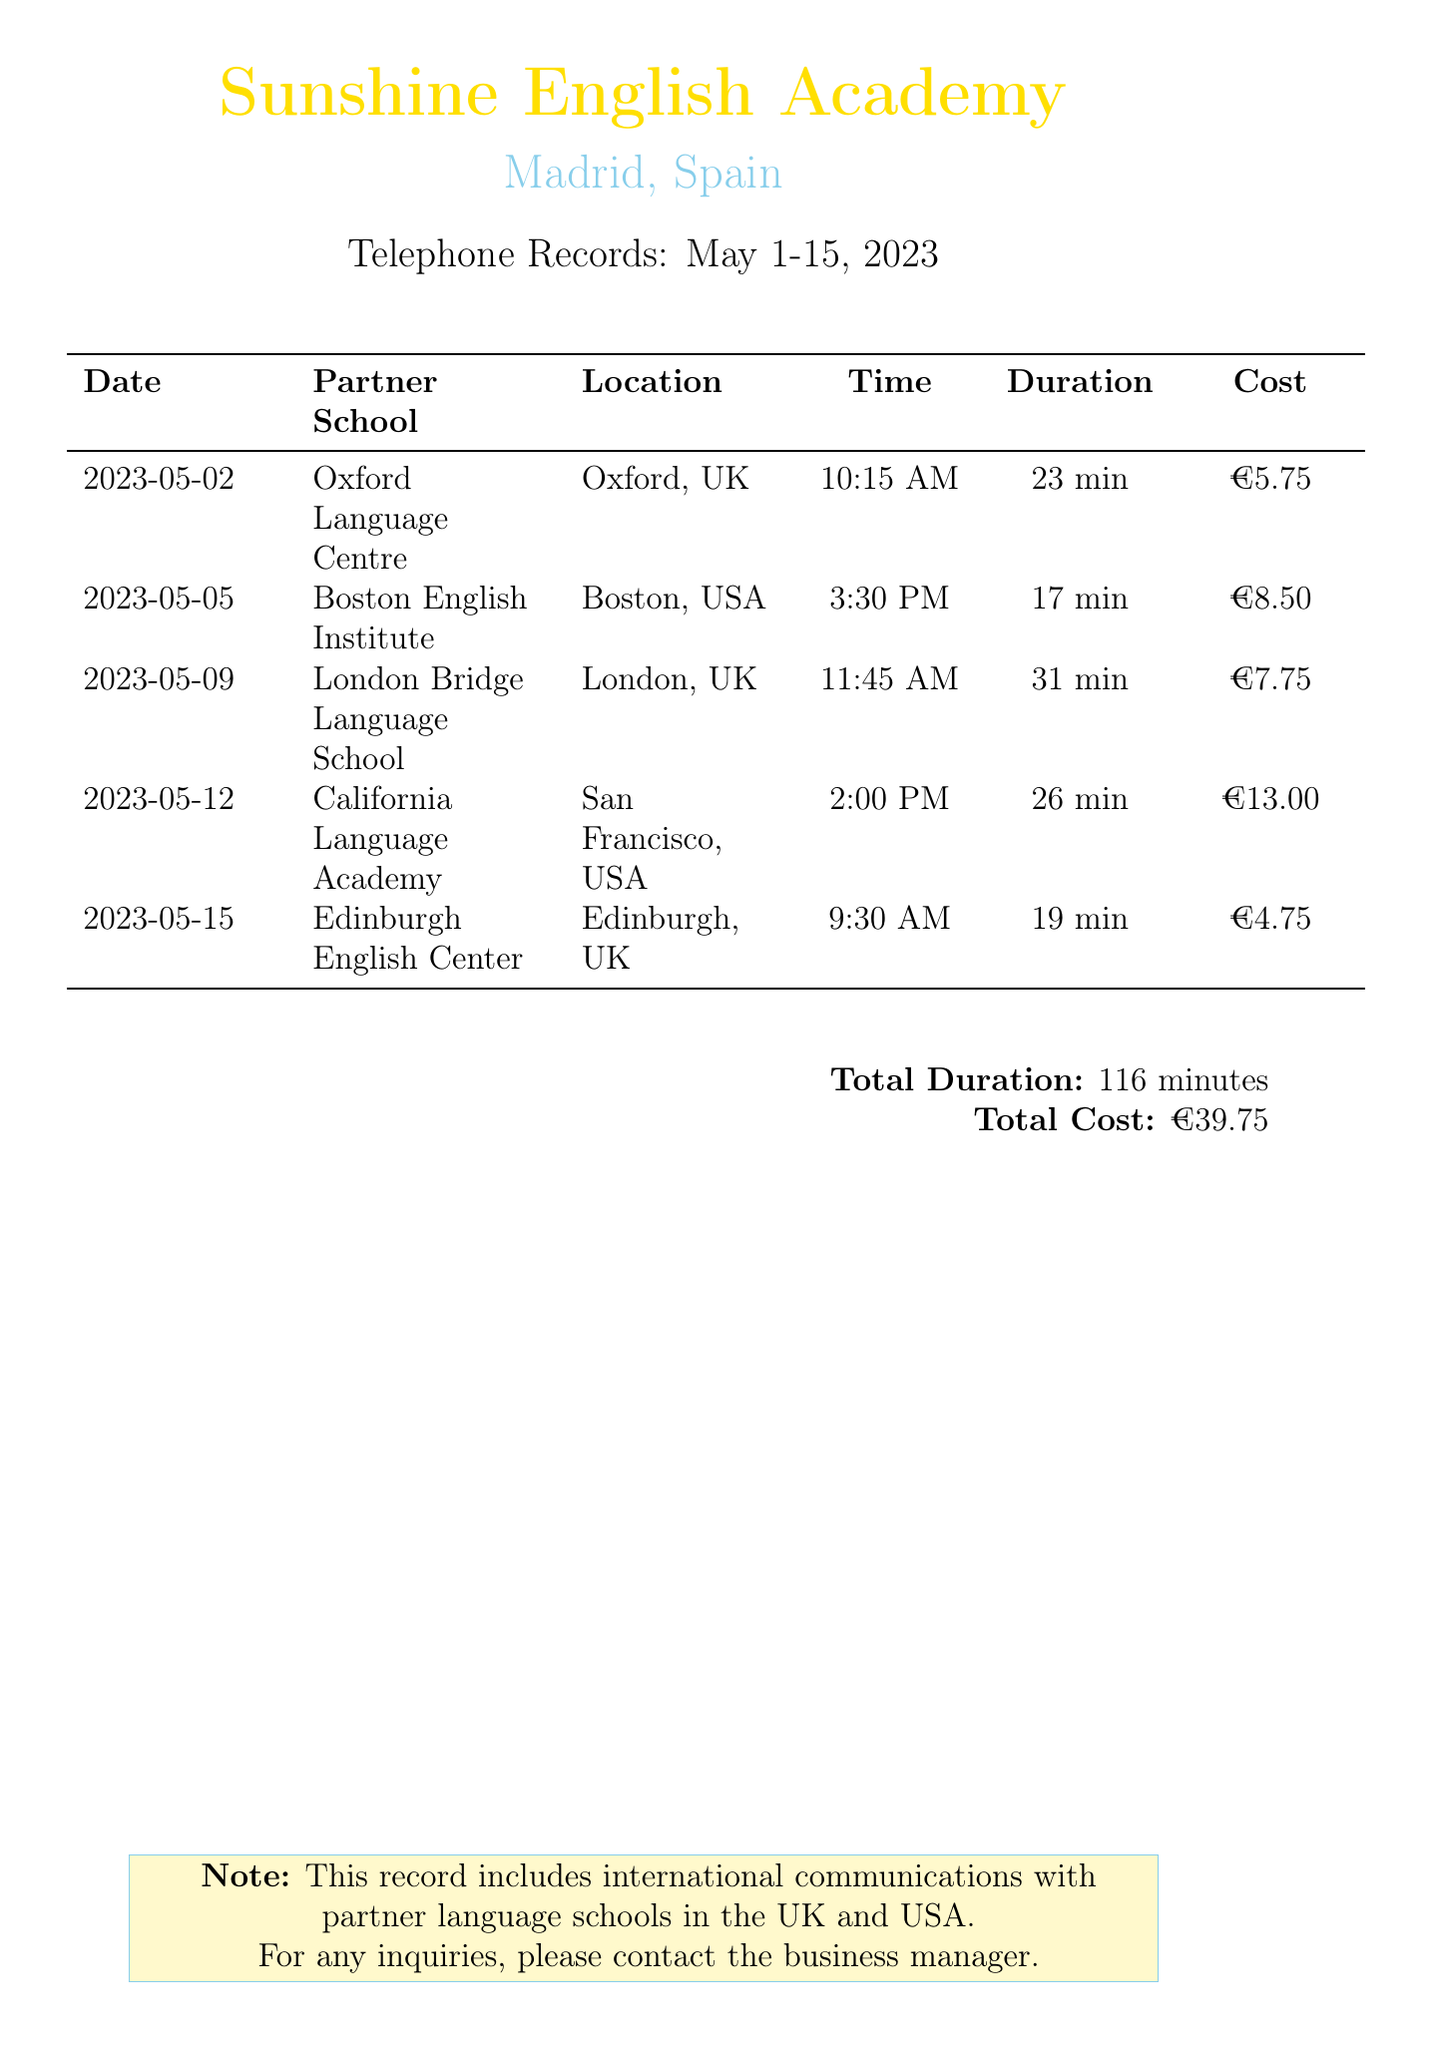What is the total duration of calls? The total duration is stated at the bottom of the document, which adds the duration of all calls made during the specified period.
Answer: 116 minutes What is the cost of the call with California Language Academy? This cost is directly listed in the call log for that particular call.
Answer: €13.00 How long was the call with the Oxford Language Centre? The duration for this call is provided in the detailed table of calls.
Answer: 23 min On what date was the call to Boston English Institute made? The date is clearly indicated in the corresponding row of the call log.
Answer: 2023-05-05 What was the total cost for all calls made? The total cost is summarized at the bottom of the document, combining all individual costs.
Answer: €39.75 Which partner school had the shortest call duration? The table shows the duration of each call, allowing for a comparison to identify the shortest one.
Answer: Edinburgh English Center How many calls were made to partner schools in the UK during this period? This can be determined by counting the entries in the table that list UK schools.
Answer: 3 What time was the call to London Bridge Language School? The time of the call is listed in the call log next to the corresponding school.
Answer: 11:45 AM Which city is Boston English Institute located in? This information is directly provided in the location column of the detailed call log.
Answer: Boston 